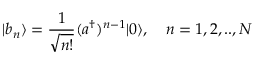<formula> <loc_0><loc_0><loc_500><loc_500>| b _ { n } \rangle = \frac { 1 } { \sqrt { n ! } } ( a ^ { \dagger } ) ^ { n - 1 } | 0 \rangle , \quad n = 1 , 2 , . . , N</formula> 